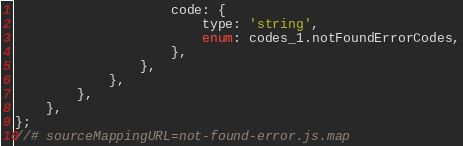<code> <loc_0><loc_0><loc_500><loc_500><_JavaScript_>                    code: {
                        type: 'string',
                        enum: codes_1.notFoundErrorCodes,
                    },
                },
            },
        },
    },
};
//# sourceMappingURL=not-found-error.js.map</code> 